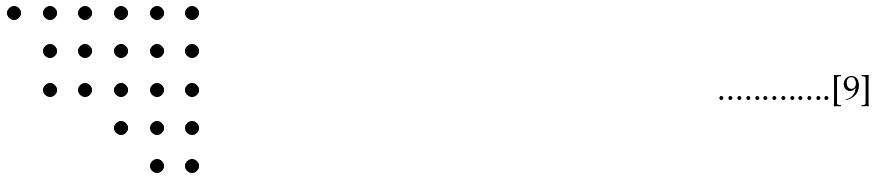Convert formula to latex. <formula><loc_0><loc_0><loc_500><loc_500>\begin{array} { c c c c c c } \bullet & \bullet & \bullet & \bullet & \bullet & \bullet \\ & \bullet & \bullet & \bullet & \bullet & \bullet \\ & \bullet & \bullet & \bullet & \bullet & \bullet \\ & & & \bullet & \bullet & \bullet \\ & & & & \bullet & \bullet \end{array}</formula> 